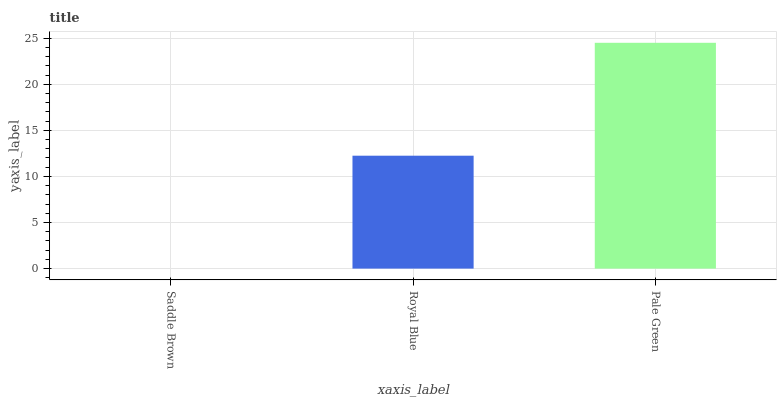Is Saddle Brown the minimum?
Answer yes or no. Yes. Is Pale Green the maximum?
Answer yes or no. Yes. Is Royal Blue the minimum?
Answer yes or no. No. Is Royal Blue the maximum?
Answer yes or no. No. Is Royal Blue greater than Saddle Brown?
Answer yes or no. Yes. Is Saddle Brown less than Royal Blue?
Answer yes or no. Yes. Is Saddle Brown greater than Royal Blue?
Answer yes or no. No. Is Royal Blue less than Saddle Brown?
Answer yes or no. No. Is Royal Blue the high median?
Answer yes or no. Yes. Is Royal Blue the low median?
Answer yes or no. Yes. Is Pale Green the high median?
Answer yes or no. No. Is Saddle Brown the low median?
Answer yes or no. No. 